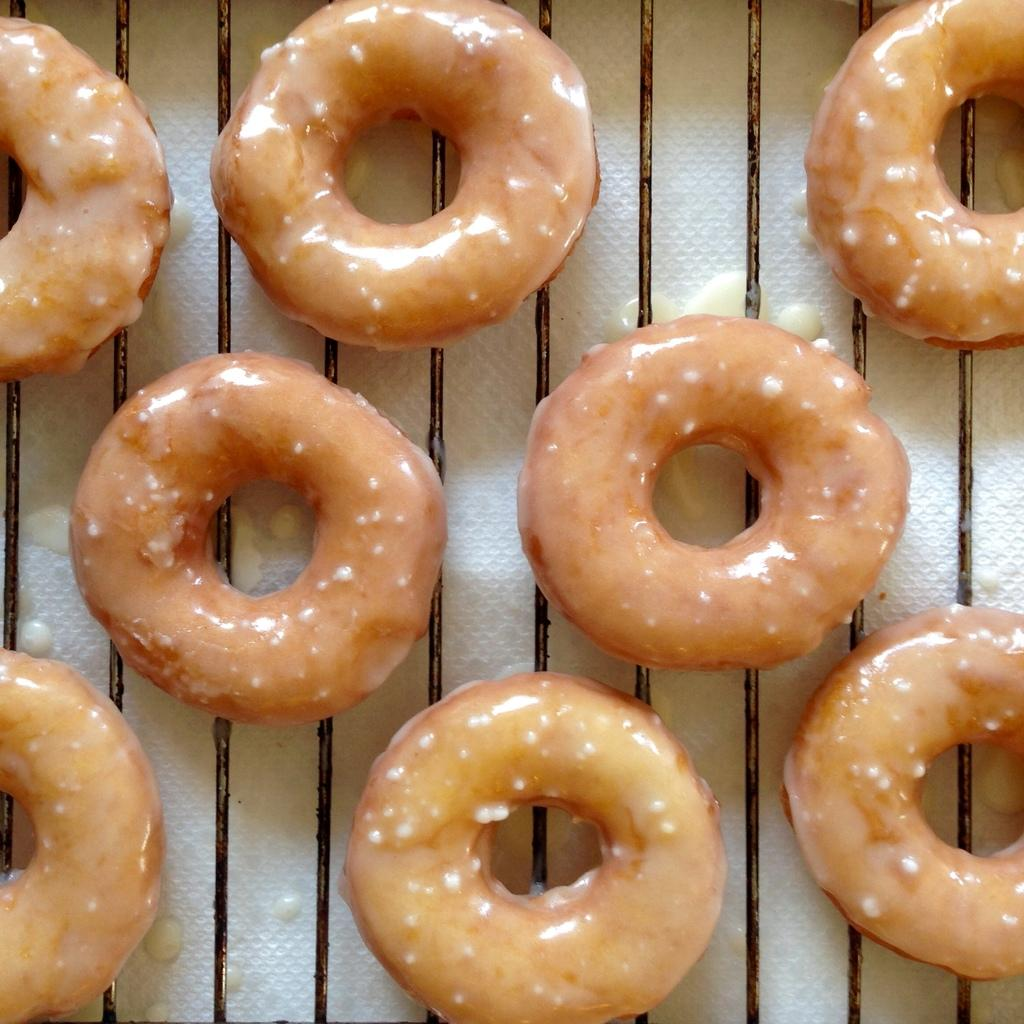What type of food is present in the image? There are doughnuts in the image. Where are the doughnuts located in the image? The doughnuts are in the center of the image. What type of ghost can be seen interacting with the doughnuts in the image? There is no ghost present in the image; it only features doughnuts. What part of the mouth can be seen in the image? There is no mouth present in the image; it only features doughnuts. 